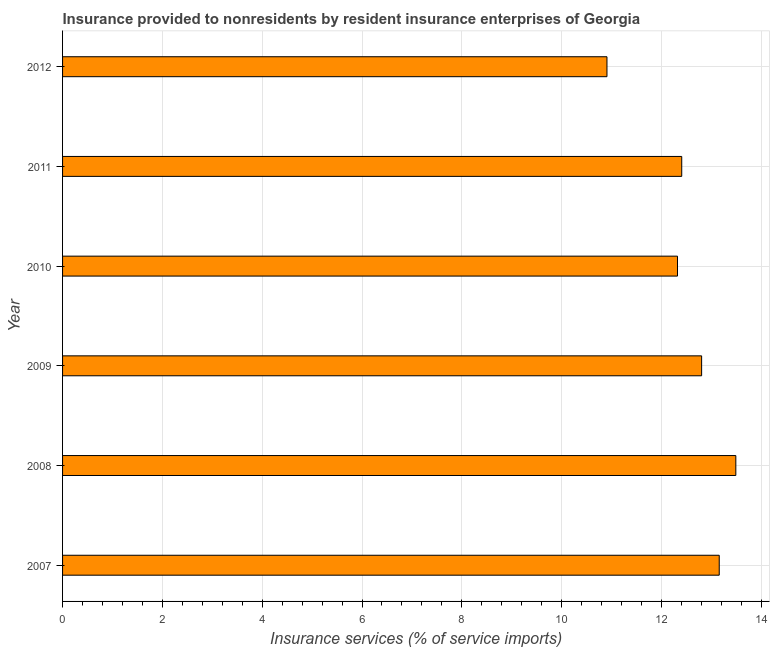Does the graph contain grids?
Keep it short and to the point. Yes. What is the title of the graph?
Provide a short and direct response. Insurance provided to nonresidents by resident insurance enterprises of Georgia. What is the label or title of the X-axis?
Ensure brevity in your answer.  Insurance services (% of service imports). What is the label or title of the Y-axis?
Provide a succinct answer. Year. What is the insurance and financial services in 2007?
Your answer should be compact. 13.16. Across all years, what is the maximum insurance and financial services?
Offer a very short reply. 13.49. Across all years, what is the minimum insurance and financial services?
Give a very brief answer. 10.91. In which year was the insurance and financial services maximum?
Offer a very short reply. 2008. What is the sum of the insurance and financial services?
Keep it short and to the point. 75.09. What is the difference between the insurance and financial services in 2009 and 2010?
Make the answer very short. 0.48. What is the average insurance and financial services per year?
Offer a terse response. 12.52. What is the median insurance and financial services?
Your answer should be compact. 12.61. In how many years, is the insurance and financial services greater than 4 %?
Offer a very short reply. 6. What is the ratio of the insurance and financial services in 2009 to that in 2010?
Offer a very short reply. 1.04. What is the difference between the highest and the second highest insurance and financial services?
Ensure brevity in your answer.  0.33. Is the sum of the insurance and financial services in 2007 and 2009 greater than the maximum insurance and financial services across all years?
Offer a very short reply. Yes. What is the difference between the highest and the lowest insurance and financial services?
Ensure brevity in your answer.  2.58. How many bars are there?
Keep it short and to the point. 6. How many years are there in the graph?
Provide a short and direct response. 6. What is the difference between two consecutive major ticks on the X-axis?
Your answer should be compact. 2. Are the values on the major ticks of X-axis written in scientific E-notation?
Offer a very short reply. No. What is the Insurance services (% of service imports) in 2007?
Ensure brevity in your answer.  13.16. What is the Insurance services (% of service imports) of 2008?
Your answer should be compact. 13.49. What is the Insurance services (% of service imports) of 2009?
Provide a short and direct response. 12.8. What is the Insurance services (% of service imports) in 2010?
Your response must be concise. 12.32. What is the Insurance services (% of service imports) of 2011?
Your answer should be compact. 12.41. What is the Insurance services (% of service imports) in 2012?
Offer a very short reply. 10.91. What is the difference between the Insurance services (% of service imports) in 2007 and 2008?
Make the answer very short. -0.33. What is the difference between the Insurance services (% of service imports) in 2007 and 2009?
Keep it short and to the point. 0.35. What is the difference between the Insurance services (% of service imports) in 2007 and 2010?
Keep it short and to the point. 0.84. What is the difference between the Insurance services (% of service imports) in 2007 and 2011?
Offer a terse response. 0.75. What is the difference between the Insurance services (% of service imports) in 2007 and 2012?
Your answer should be very brief. 2.25. What is the difference between the Insurance services (% of service imports) in 2008 and 2009?
Provide a succinct answer. 0.69. What is the difference between the Insurance services (% of service imports) in 2008 and 2010?
Offer a terse response. 1.17. What is the difference between the Insurance services (% of service imports) in 2008 and 2011?
Your response must be concise. 1.08. What is the difference between the Insurance services (% of service imports) in 2008 and 2012?
Keep it short and to the point. 2.58. What is the difference between the Insurance services (% of service imports) in 2009 and 2010?
Your response must be concise. 0.48. What is the difference between the Insurance services (% of service imports) in 2009 and 2011?
Provide a short and direct response. 0.4. What is the difference between the Insurance services (% of service imports) in 2009 and 2012?
Provide a succinct answer. 1.9. What is the difference between the Insurance services (% of service imports) in 2010 and 2011?
Your response must be concise. -0.09. What is the difference between the Insurance services (% of service imports) in 2010 and 2012?
Give a very brief answer. 1.41. What is the difference between the Insurance services (% of service imports) in 2011 and 2012?
Provide a short and direct response. 1.5. What is the ratio of the Insurance services (% of service imports) in 2007 to that in 2009?
Your response must be concise. 1.03. What is the ratio of the Insurance services (% of service imports) in 2007 to that in 2010?
Offer a terse response. 1.07. What is the ratio of the Insurance services (% of service imports) in 2007 to that in 2011?
Ensure brevity in your answer.  1.06. What is the ratio of the Insurance services (% of service imports) in 2007 to that in 2012?
Your answer should be compact. 1.21. What is the ratio of the Insurance services (% of service imports) in 2008 to that in 2009?
Keep it short and to the point. 1.05. What is the ratio of the Insurance services (% of service imports) in 2008 to that in 2010?
Your answer should be compact. 1.09. What is the ratio of the Insurance services (% of service imports) in 2008 to that in 2011?
Offer a terse response. 1.09. What is the ratio of the Insurance services (% of service imports) in 2008 to that in 2012?
Keep it short and to the point. 1.24. What is the ratio of the Insurance services (% of service imports) in 2009 to that in 2010?
Provide a succinct answer. 1.04. What is the ratio of the Insurance services (% of service imports) in 2009 to that in 2011?
Your answer should be compact. 1.03. What is the ratio of the Insurance services (% of service imports) in 2009 to that in 2012?
Your answer should be very brief. 1.17. What is the ratio of the Insurance services (% of service imports) in 2010 to that in 2012?
Make the answer very short. 1.13. What is the ratio of the Insurance services (% of service imports) in 2011 to that in 2012?
Your answer should be very brief. 1.14. 